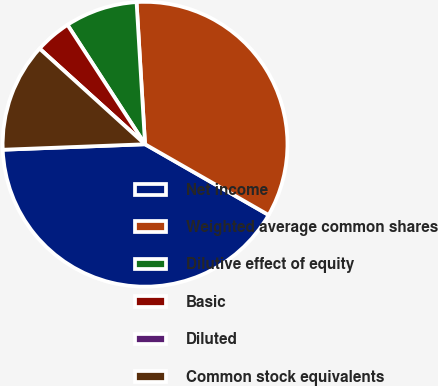Convert chart to OTSL. <chart><loc_0><loc_0><loc_500><loc_500><pie_chart><fcel>Net income<fcel>Weighted average common shares<fcel>Dilutive effect of equity<fcel>Basic<fcel>Diluted<fcel>Common stock equivalents<nl><fcel>41.11%<fcel>34.22%<fcel>8.22%<fcel>4.11%<fcel>0.0%<fcel>12.33%<nl></chart> 